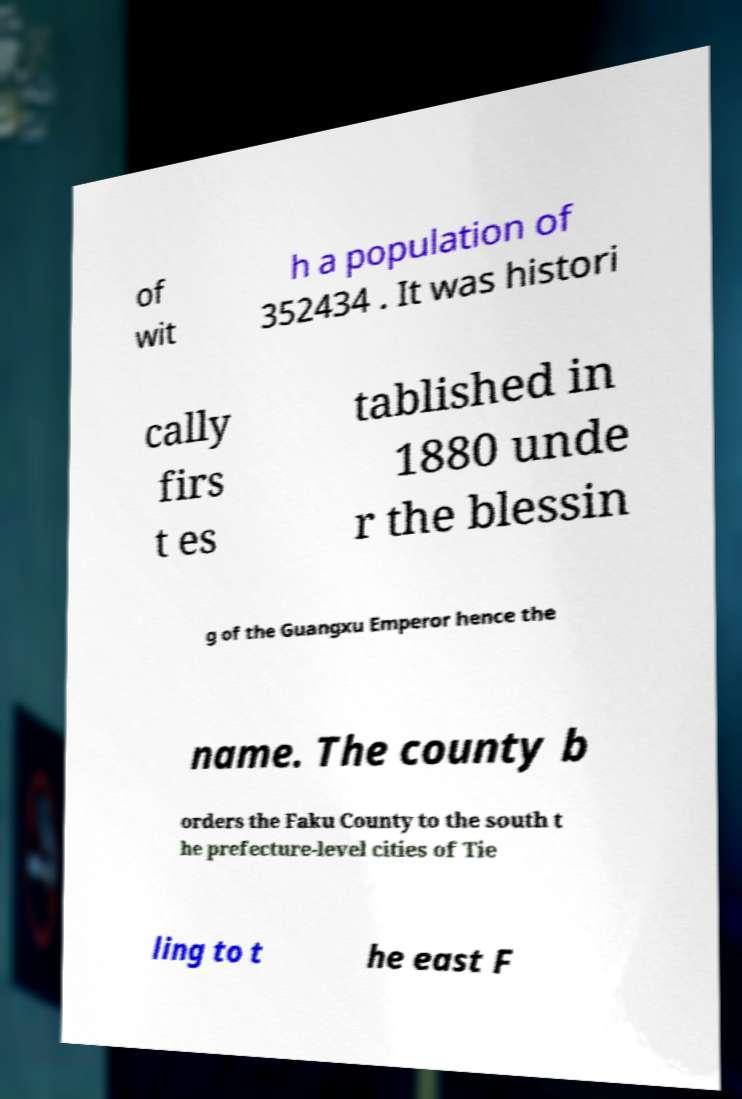Can you accurately transcribe the text from the provided image for me? of wit h a population of 352434 . It was histori cally firs t es tablished in 1880 unde r the blessin g of the Guangxu Emperor hence the name. The county b orders the Faku County to the south t he prefecture-level cities of Tie ling to t he east F 